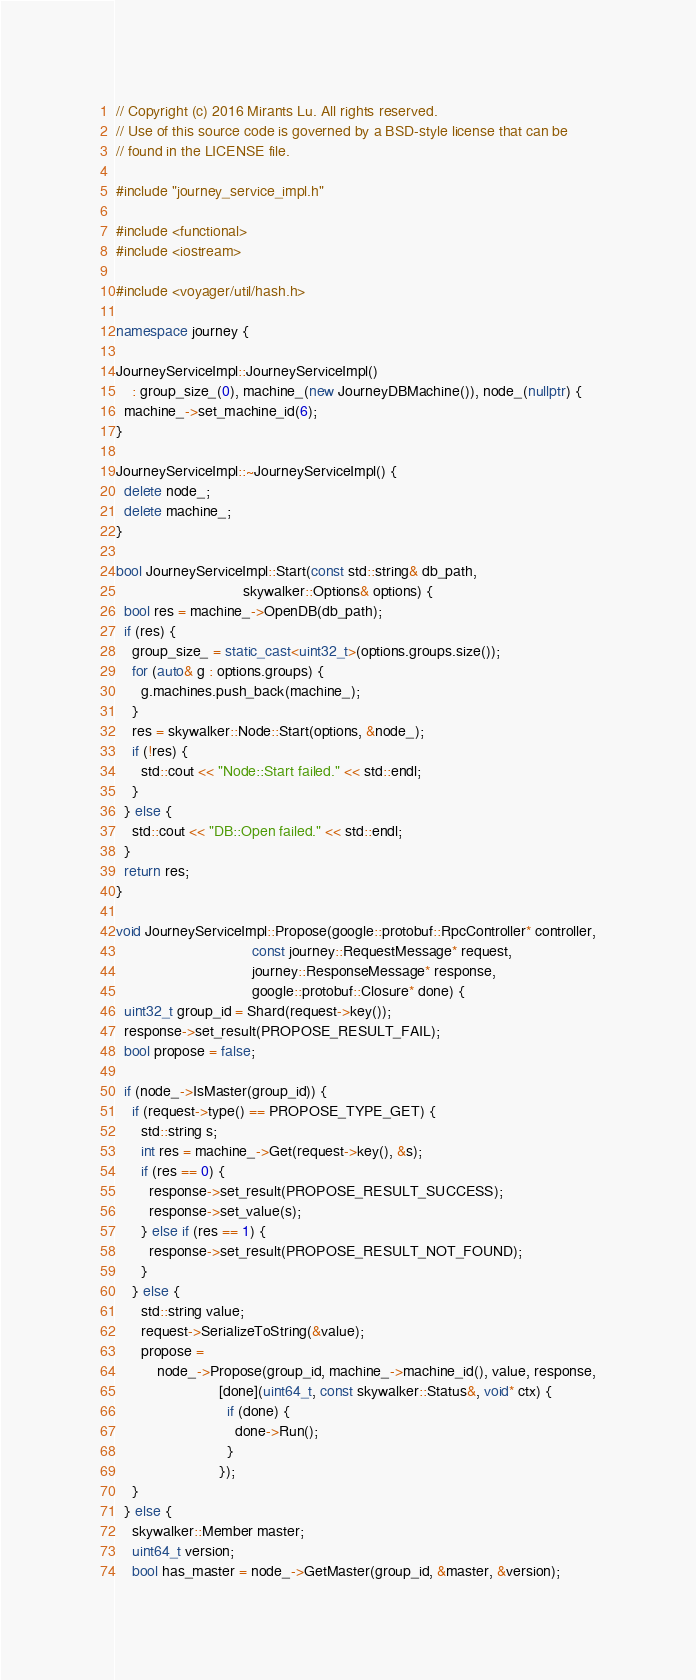Convert code to text. <code><loc_0><loc_0><loc_500><loc_500><_C++_>// Copyright (c) 2016 Mirants Lu. All rights reserved.
// Use of this source code is governed by a BSD-style license that can be
// found in the LICENSE file.

#include "journey_service_impl.h"

#include <functional>
#include <iostream>

#include <voyager/util/hash.h>

namespace journey {

JourneyServiceImpl::JourneyServiceImpl()
    : group_size_(0), machine_(new JourneyDBMachine()), node_(nullptr) {
  machine_->set_machine_id(6);
}

JourneyServiceImpl::~JourneyServiceImpl() {
  delete node_;
  delete machine_;
}

bool JourneyServiceImpl::Start(const std::string& db_path,
                               skywalker::Options& options) {
  bool res = machine_->OpenDB(db_path);
  if (res) {
    group_size_ = static_cast<uint32_t>(options.groups.size());
    for (auto& g : options.groups) {
      g.machines.push_back(machine_);
    }
    res = skywalker::Node::Start(options, &node_);
    if (!res) {
      std::cout << "Node::Start failed." << std::endl;
    }
  } else {
    std::cout << "DB::Open failed." << std::endl;
  }
  return res;
}

void JourneyServiceImpl::Propose(google::protobuf::RpcController* controller,
                                 const journey::RequestMessage* request,
                                 journey::ResponseMessage* response,
                                 google::protobuf::Closure* done) {
  uint32_t group_id = Shard(request->key());
  response->set_result(PROPOSE_RESULT_FAIL);
  bool propose = false;

  if (node_->IsMaster(group_id)) {
    if (request->type() == PROPOSE_TYPE_GET) {
      std::string s;
      int res = machine_->Get(request->key(), &s);
      if (res == 0) {
        response->set_result(PROPOSE_RESULT_SUCCESS);
        response->set_value(s);
      } else if (res == 1) {
        response->set_result(PROPOSE_RESULT_NOT_FOUND);
      }
    } else {
      std::string value;
      request->SerializeToString(&value);
      propose =
          node_->Propose(group_id, machine_->machine_id(), value, response,
                         [done](uint64_t, const skywalker::Status&, void* ctx) {
                           if (done) {
                             done->Run();
                           }
                         });
    }
  } else {
    skywalker::Member master;
    uint64_t version;
    bool has_master = node_->GetMaster(group_id, &master, &version);</code> 